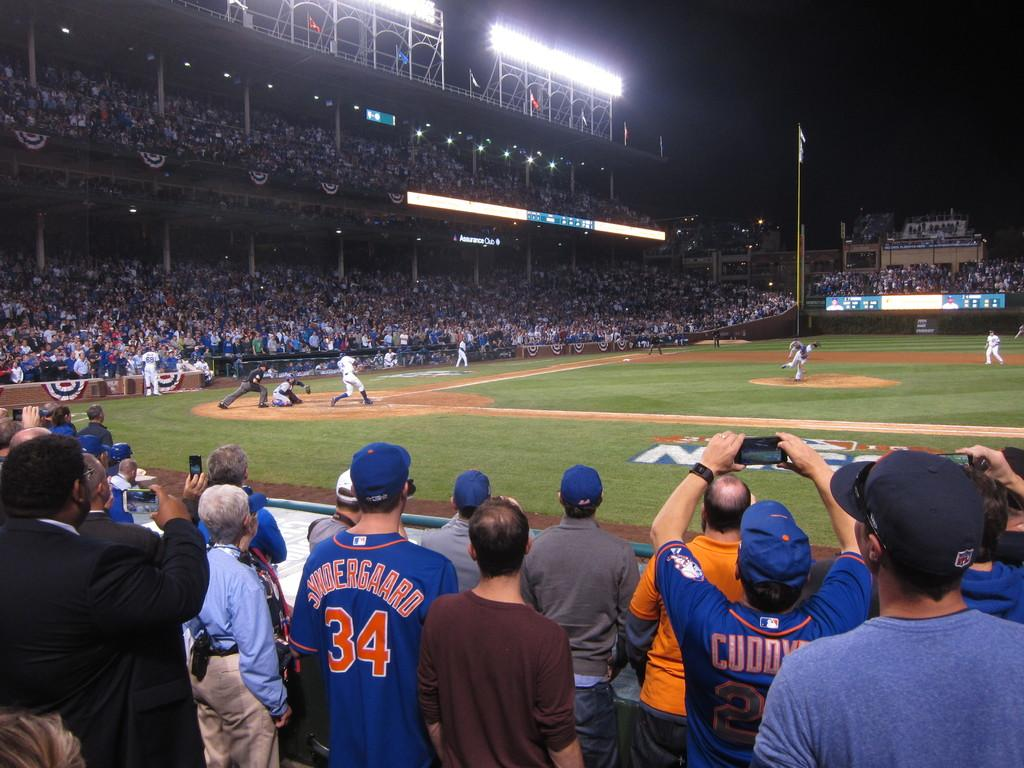<image>
Share a concise interpretation of the image provided. A crowd watching the baseball game, one of the fans is wearing a jersey with the number 34 on it. 